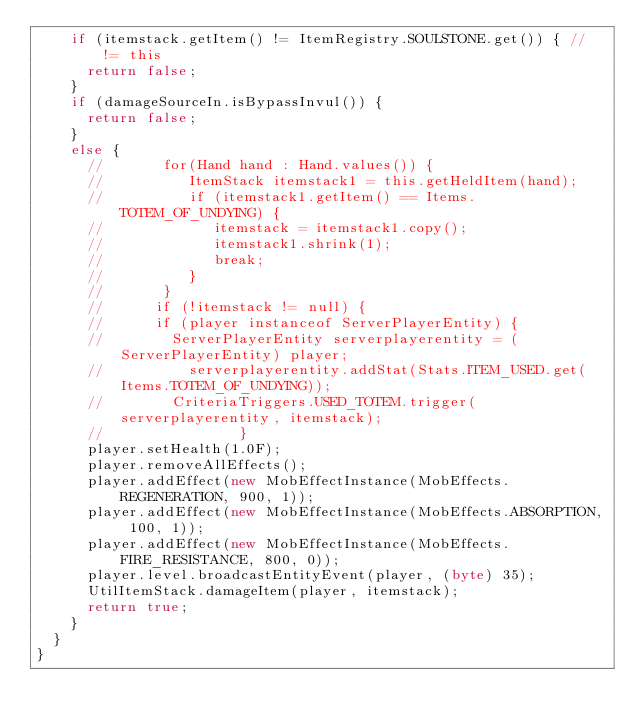Convert code to text. <code><loc_0><loc_0><loc_500><loc_500><_Java_>    if (itemstack.getItem() != ItemRegistry.SOULSTONE.get()) { // != this
      return false;
    }
    if (damageSourceIn.isBypassInvul()) {
      return false;
    }
    else {
      //       for(Hand hand : Hand.values()) {
      //          ItemStack itemstack1 = this.getHeldItem(hand);
      //          if (itemstack1.getItem() == Items.TOTEM_OF_UNDYING) {
      //             itemstack = itemstack1.copy();
      //             itemstack1.shrink(1);
      //             break;
      //          }
      //       }
      //      if (!itemstack != null) {
      //      if (player instanceof ServerPlayerEntity) {
      //        ServerPlayerEntity serverplayerentity = (ServerPlayerEntity) player;
      //          serverplayerentity.addStat(Stats.ITEM_USED.get(Items.TOTEM_OF_UNDYING));
      //        CriteriaTriggers.USED_TOTEM.trigger(serverplayerentity, itemstack);
      //                }
      player.setHealth(1.0F);
      player.removeAllEffects();
      player.addEffect(new MobEffectInstance(MobEffects.REGENERATION, 900, 1));
      player.addEffect(new MobEffectInstance(MobEffects.ABSORPTION, 100, 1));
      player.addEffect(new MobEffectInstance(MobEffects.FIRE_RESISTANCE, 800, 0));
      player.level.broadcastEntityEvent(player, (byte) 35);
      UtilItemStack.damageItem(player, itemstack);
      return true;
    }
  }
}
</code> 